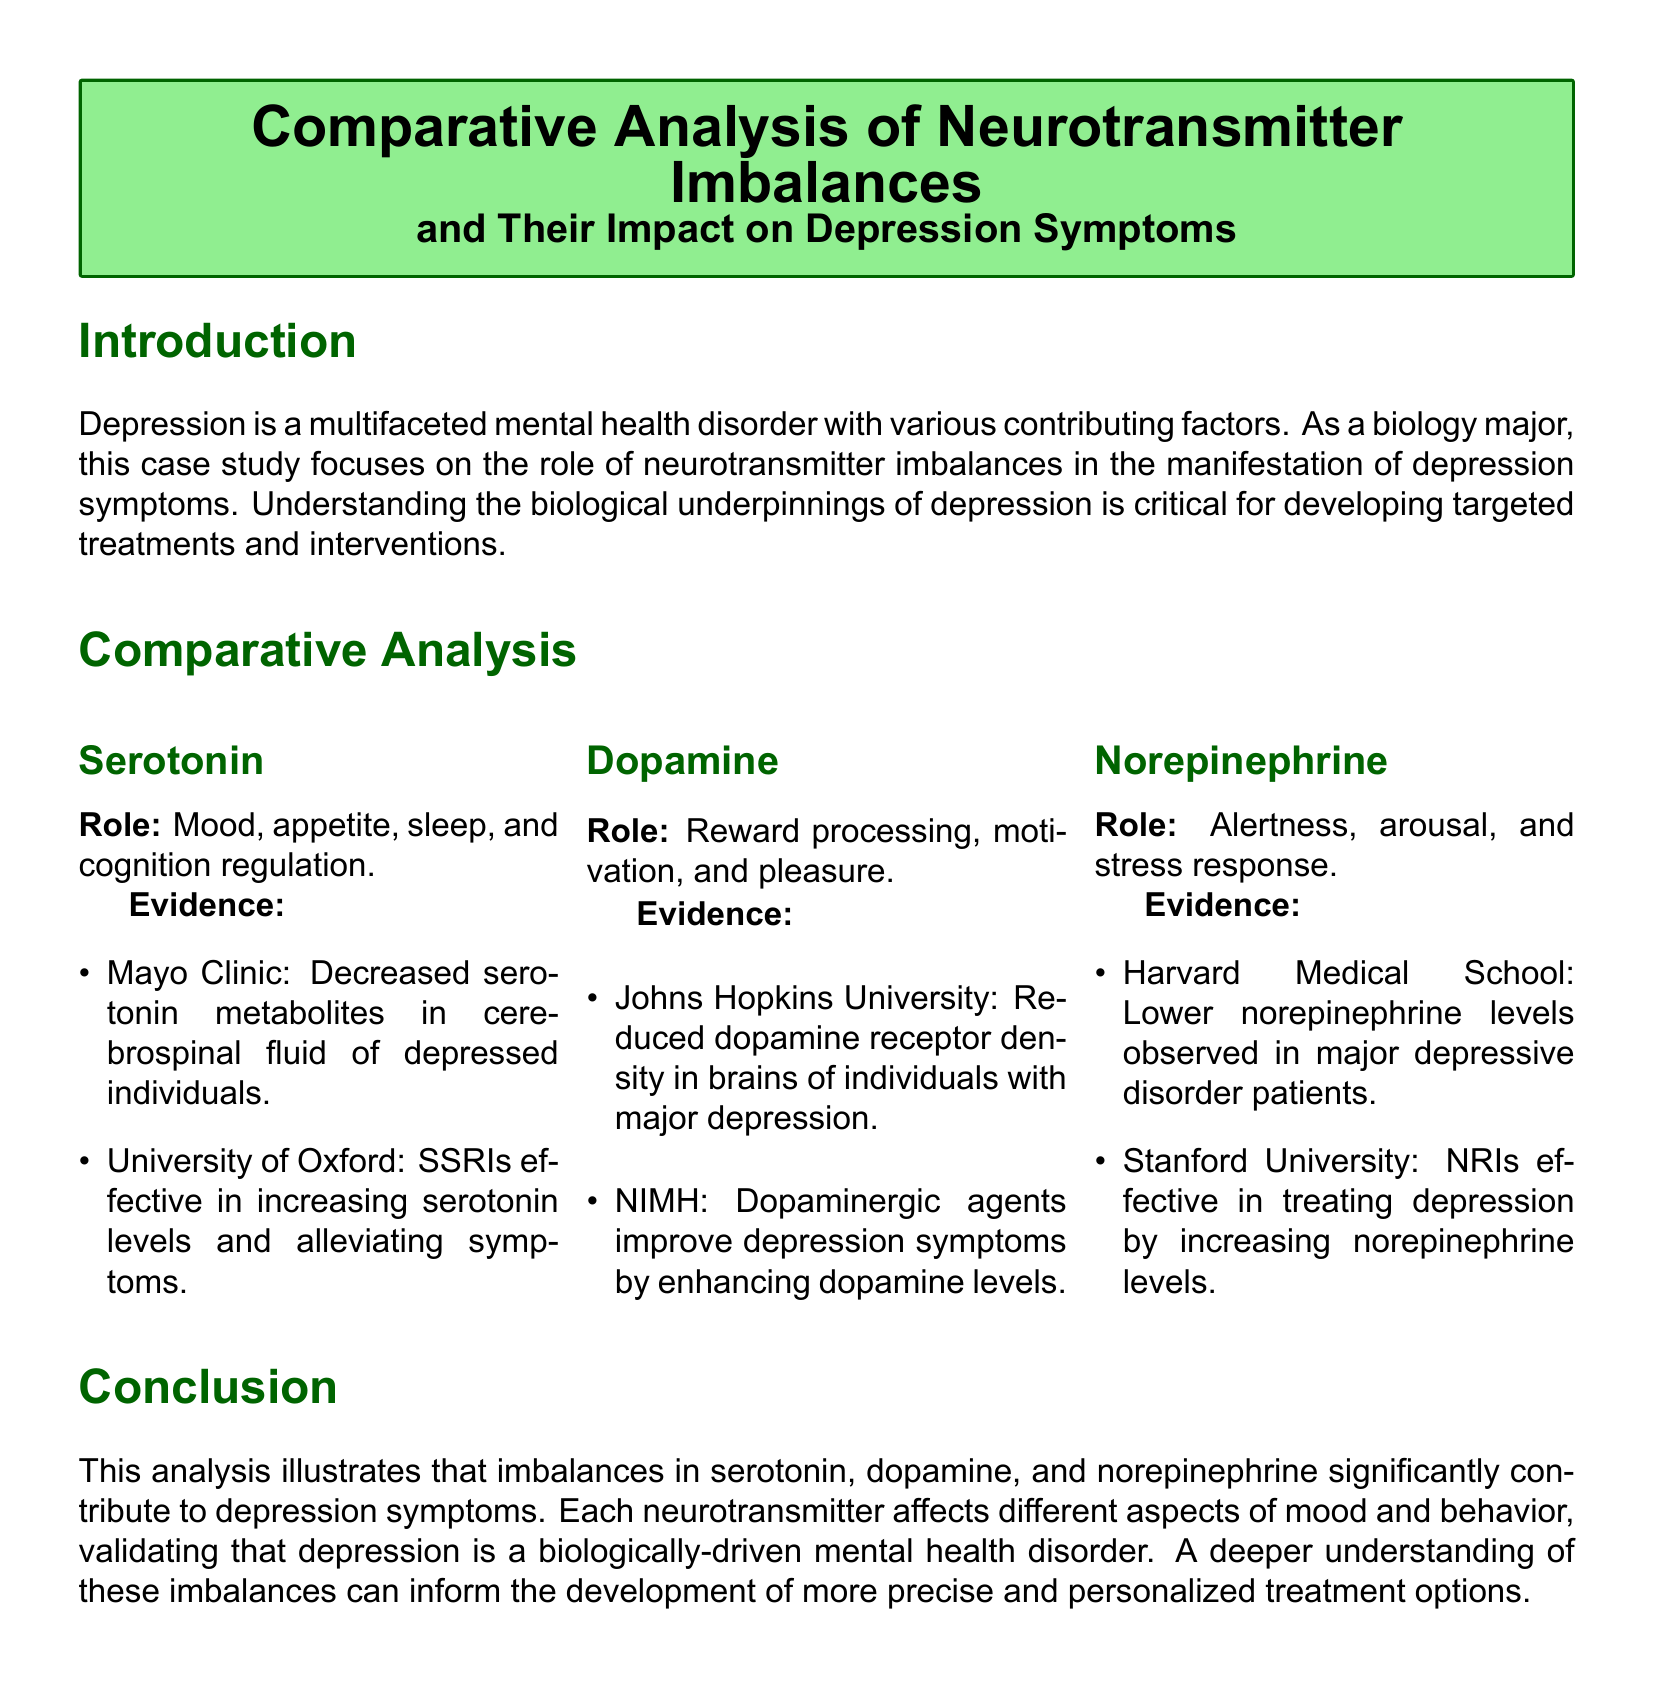What is the main focus of this case study? The main focus of the case study is the role of neurotransmitter imbalances in the manifestation of depression symptoms.
Answer: neurotransmitter imbalances What neurotransmitter is associated with mood regulation? The document specifies that serotonin is involved in mood regulation among other functions.
Answer: serotonin Which educational institution reported on the effectiveness of SSRIs? The University of Oxford reported on the effectiveness of SSRIs in increasing serotonin levels and alleviating symptoms.
Answer: University of Oxford What is one role of norepinephrine mentioned in the document? The document highlights alertness as one of the roles of norepinephrine.
Answer: alertness What type of agents improve depression symptoms by enhancing dopamine levels? The document states that dopaminergic agents improve depression symptoms by enhancing dopamine levels.
Answer: dopaminergic agents How many neurotransmitters are analyzed in this case study? The case study analyzes three neurotransmitters which are serotonin, dopamine, and norepinephrine.
Answer: three Which medical school noted lower norepinephrine levels in depression patients? Harvard Medical School noted lower norepinephrine levels in patients with major depressive disorder.
Answer: Harvard Medical School What year was the study on dopamine receptor density published? The study on dopamine receptor density was published in 2021.
Answer: 2021 